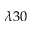<formula> <loc_0><loc_0><loc_500><loc_500>\lambda 3 0</formula> 